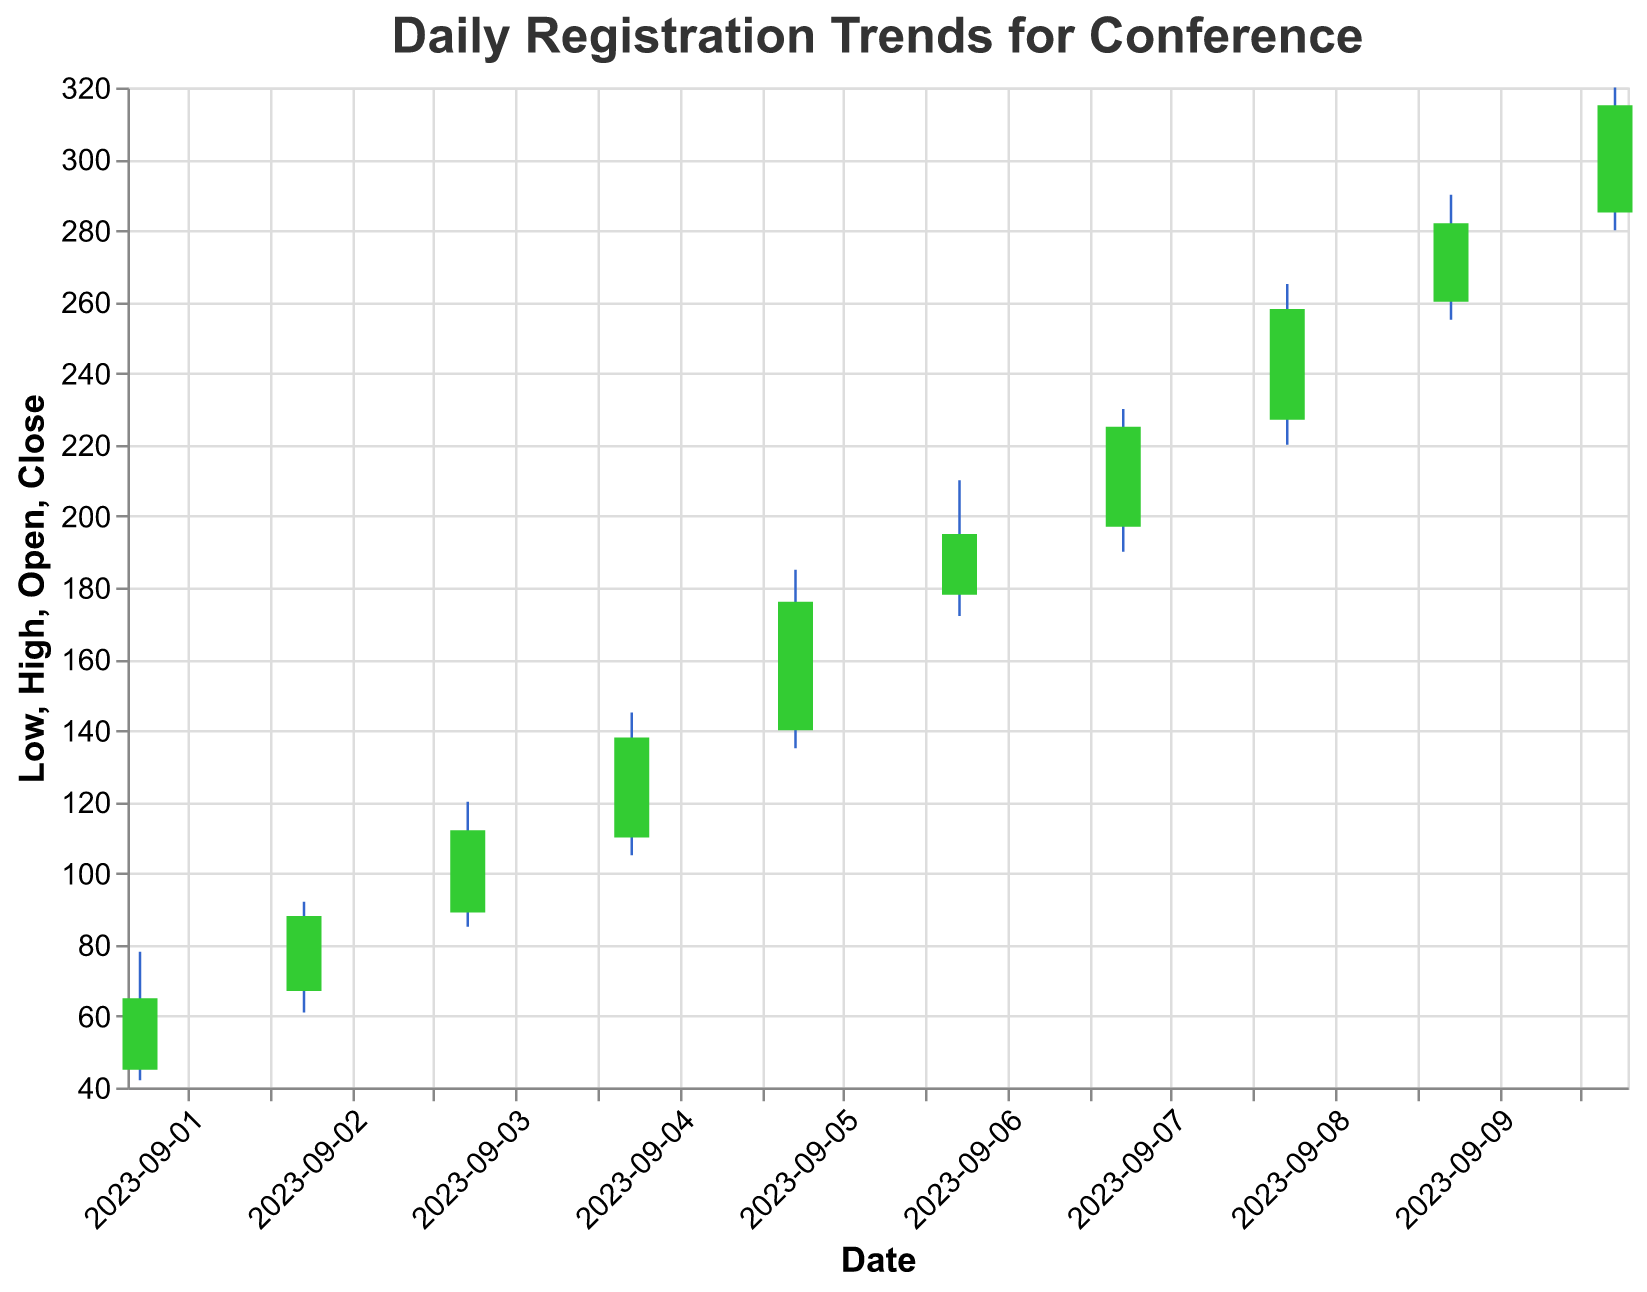What is the title of the chart? The title is located at the top of the chart in a larger font and is designed to summarize the main subject of the visual representation.
Answer: Daily Registration Trends for Conference How many days are shown in the chart? Each date on the x-axis represents a day, and counting the individual date labels will give the total number of days displayed.
Answer: 10 What was the opening number of registrations on 2023-09-02? Locate the data point for 2023-09-02 and check the 'Open' value, which represents the starting number of registrations for that day.
Answer: 67 Did the closing number of registrations increase or decrease from 2023-09-05 to 2023-09-06? Compare the 'Close' value for both dates. The 'Close' value on 2023-09-05 was 176, and on 2023-09-06 it was 195.
Answer: Increase Which day had the highest peak registration? Identify the day with the maximum 'High' value by comparing the peaks for each date.
Answer: 2023-09-10 What is the range of registrations on the day with the lowest opening number? The lowest 'Open' value is 45 on 2023-09-01. The range can be calculated by subtracting the 'Low' value from the 'High' value on that day: 78 - 42.
Answer: 36 Between which days did the closing number increase the most? Calculate the differences in 'Close' values for consecutive days and find the pair with the maximum increase. For example:
2023-09-01 to 2023-09-02: 88 - 65 = 23
2023-09-02 to 2023-09-03: 112 - 88 = 24
and so on.
Answer: 2023-09-05 to 2023-09-06 What was the lowest registration number recorded during the 10-day period? Look for the minimum 'Low' value across all the days listed in the chart data.
Answer: 42 Was there any day where the opening and closing registrations were the same? Check if any 'Open' value is equal to its corresponding 'Close' value for the days in question.
Answer: No 